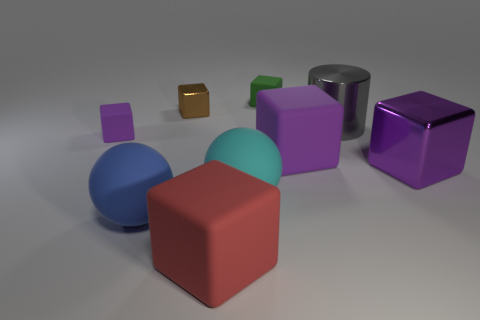Is the size of the cyan thing the same as the gray cylinder?
Give a very brief answer. Yes. What number of cubes are purple metallic objects or green objects?
Give a very brief answer. 2. There is a big metallic object that is to the left of the purple metal cube; how many big blue things are to the left of it?
Keep it short and to the point. 1. Do the red matte object and the brown thing have the same shape?
Provide a succinct answer. Yes. The green thing that is the same shape as the brown shiny object is what size?
Offer a terse response. Small. There is a cyan object that is in front of the metal thing that is in front of the large gray metal object; what shape is it?
Your answer should be compact. Sphere. What size is the red thing?
Your response must be concise. Large. What is the shape of the tiny green thing?
Provide a short and direct response. Cube. Does the brown thing have the same shape as the purple matte thing behind the large purple rubber cube?
Your answer should be very brief. Yes. Do the big shiny thing that is right of the big gray cylinder and the brown object have the same shape?
Make the answer very short. Yes. 